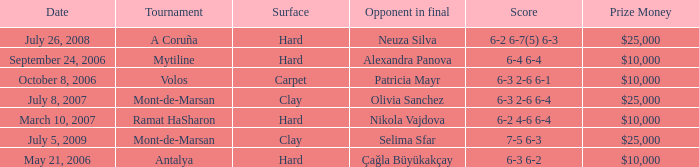What is the score of the hard court Ramat Hasharon tournament? 6-2 4-6 6-4. 